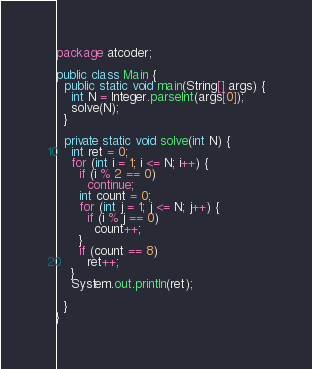<code> <loc_0><loc_0><loc_500><loc_500><_Java_>package atcoder;

public class Main {
  public static void main(String[] args) {
    int N = Integer.parseInt(args[0]);
    solve(N);
  }

  private static void solve(int N) {
    int ret = 0;
    for (int i = 1; i <= N; i++) {
      if (i % 2 == 0)
        continue;
      int count = 0;
      for (int j = 1; j <= N; j++) {
        if (i % j == 0)
          count++;
      }
      if (count == 8)
        ret++;
    }
    System.out.println(ret);

  }
}
</code> 